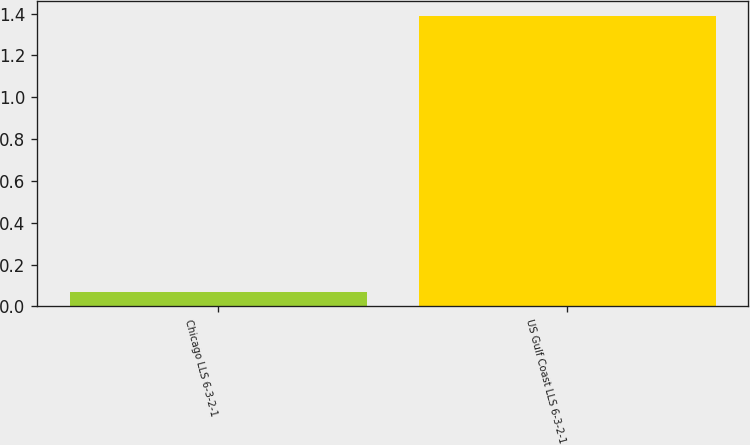Convert chart to OTSL. <chart><loc_0><loc_0><loc_500><loc_500><bar_chart><fcel>Chicago LLS 6-3-2-1<fcel>US Gulf Coast LLS 6-3-2-1<nl><fcel>0.07<fcel>1.39<nl></chart> 